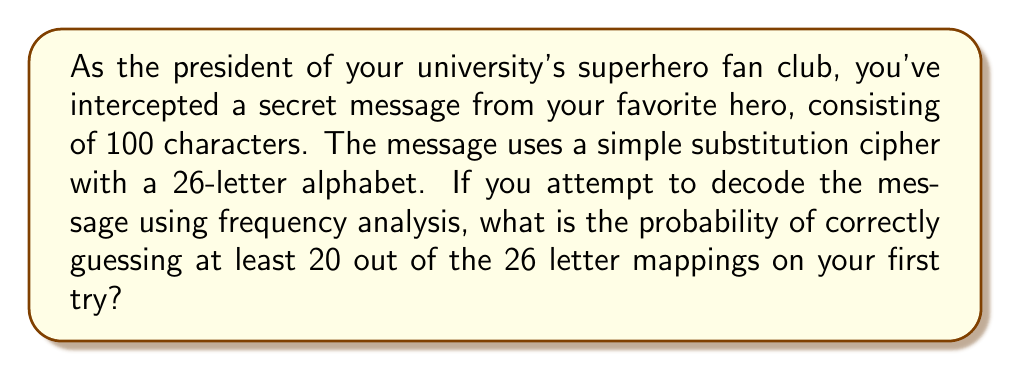Teach me how to tackle this problem. Let's approach this step-by-step:

1) In a simple substitution cipher with a 26-letter alphabet, there are 26! possible mappings.

2) We want to calculate the probability of guessing at least 20 out of 26 mappings correctly. This is equivalent to the probability of guessing 20, 21, 22, 23, 24, 25, or 26 mappings correctly.

3) The number of ways to choose k correct mappings out of 26 is given by the combination formula:

   $${26 \choose k} = \frac{26!}{k!(26-k)!}$$

4) For each correct mapping, we have 1 way to choose it, and for each incorrect mapping, we have 25 ways to choose it (as it can be any of the 25 remaining letters).

5) Therefore, the number of ways to have exactly k correct mappings is:

   $${26 \choose k} \cdot 1^k \cdot 25^{26-k}$$

6) The probability of having exactly k correct mappings is:

   $$P(k) = \frac{{26 \choose k} \cdot 1^k \cdot 25^{26-k}}{26!}$$

7) We want the sum of these probabilities for k = 20 to 26:

   $$P(\text{at least 20 correct}) = \sum_{k=20}^{26} \frac{{26 \choose k} \cdot 25^{26-k}}{26!}$$

8) Calculating this sum:

   $$\begin{align*}
   P &= \frac{1}{26!}({26 \choose 20} \cdot 25^6 + {26 \choose 21} \cdot 25^5 + {26 \choose 22} \cdot 25^4 + {26 \choose 23} \cdot 25^3 + {26 \choose 24} \cdot 25^2 + {26 \choose 25} \cdot 25^1 + {26 \choose 26} \cdot 25^0) \\
   &\approx 1.8083 \times 10^{-18}
   \end{align*}$$
Answer: $1.8083 \times 10^{-18}$ 